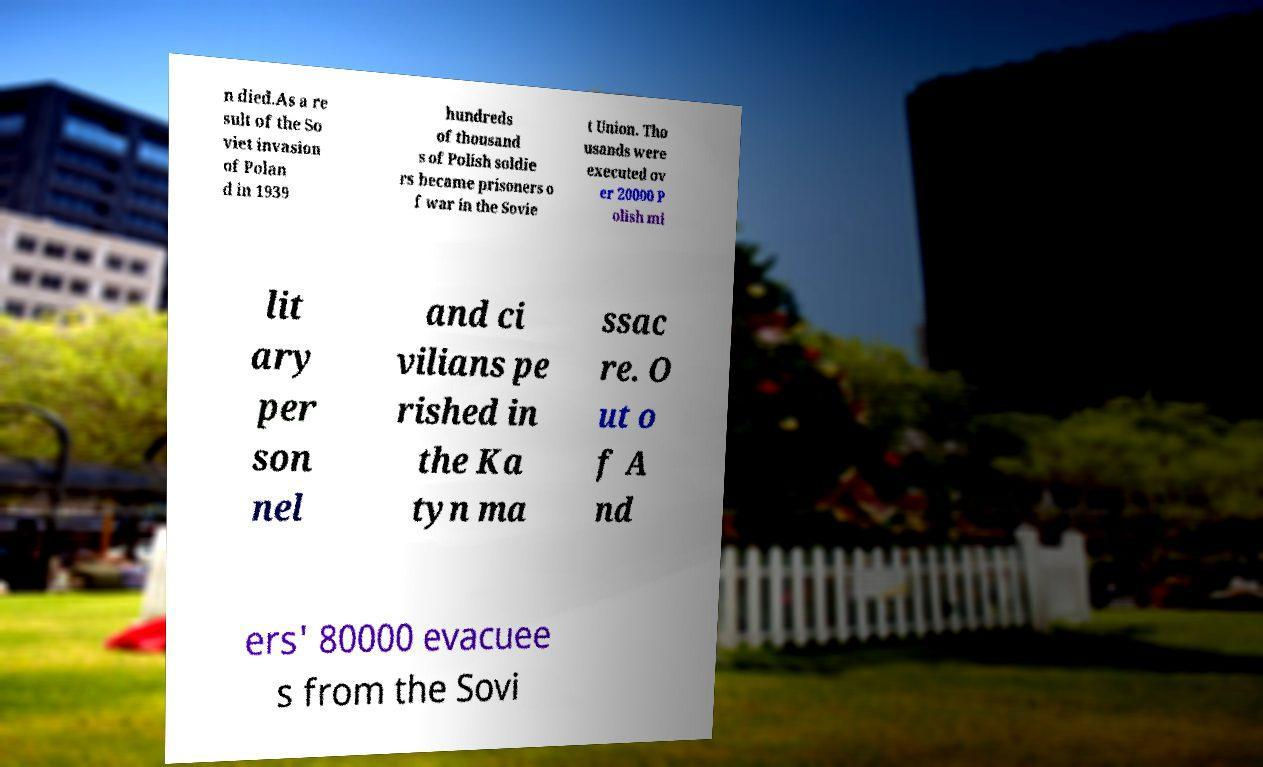Please identify and transcribe the text found in this image. n died.As a re sult of the So viet invasion of Polan d in 1939 hundreds of thousand s of Polish soldie rs became prisoners o f war in the Sovie t Union. Tho usands were executed ov er 20000 P olish mi lit ary per son nel and ci vilians pe rished in the Ka tyn ma ssac re. O ut o f A nd ers' 80000 evacuee s from the Sovi 